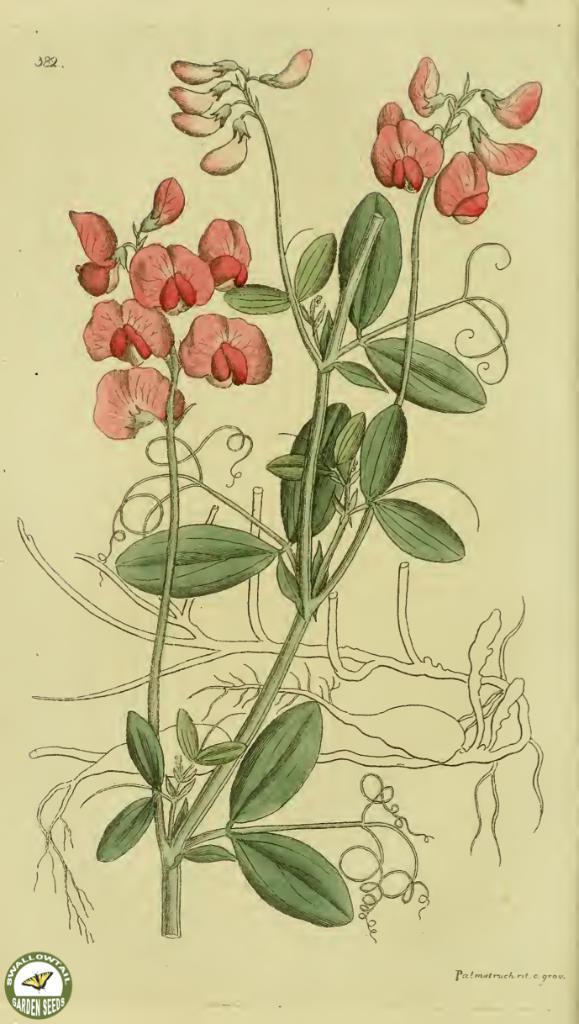Describe this image in one or two sentences. In this picture, we see the drawing of the plant which has the flowers and the buds. These flowers are in red color. In the background, it is white in color. This picture might be drawn on the white paper. 